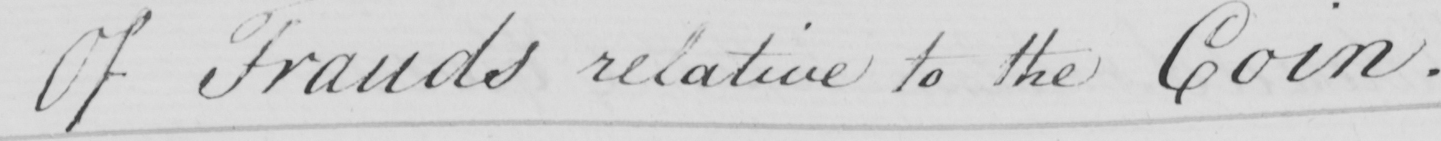Transcribe the text shown in this historical manuscript line. Of Frauds relative to the Coin . 